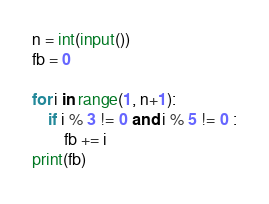Convert code to text. <code><loc_0><loc_0><loc_500><loc_500><_Python_>n = int(input())
fb = 0

for i in range(1, n+1):
    if i % 3 != 0 and i % 5 != 0 :
        fb += i
print(fb)
</code> 